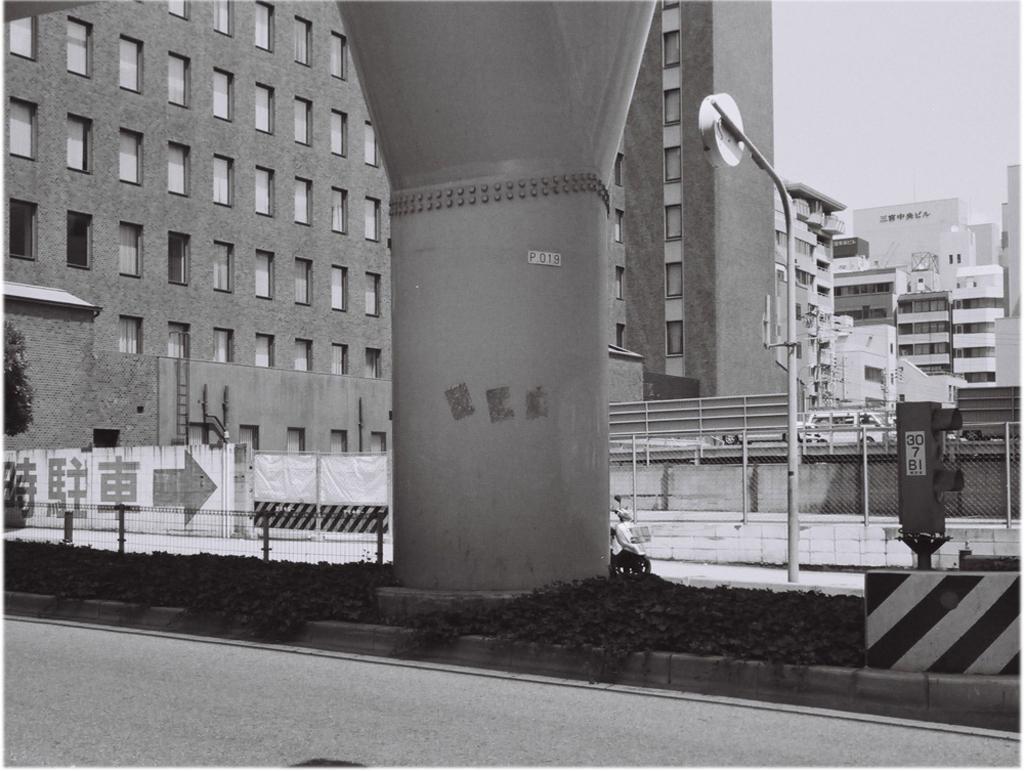Could you give a brief overview of what you see in this image? This picture is clicked outside. In the center we can see a pillar, metal rods, net and some plants. In the background we can see the buildings and we can see the windows of the buildings and we can see the sky and some other objects. 